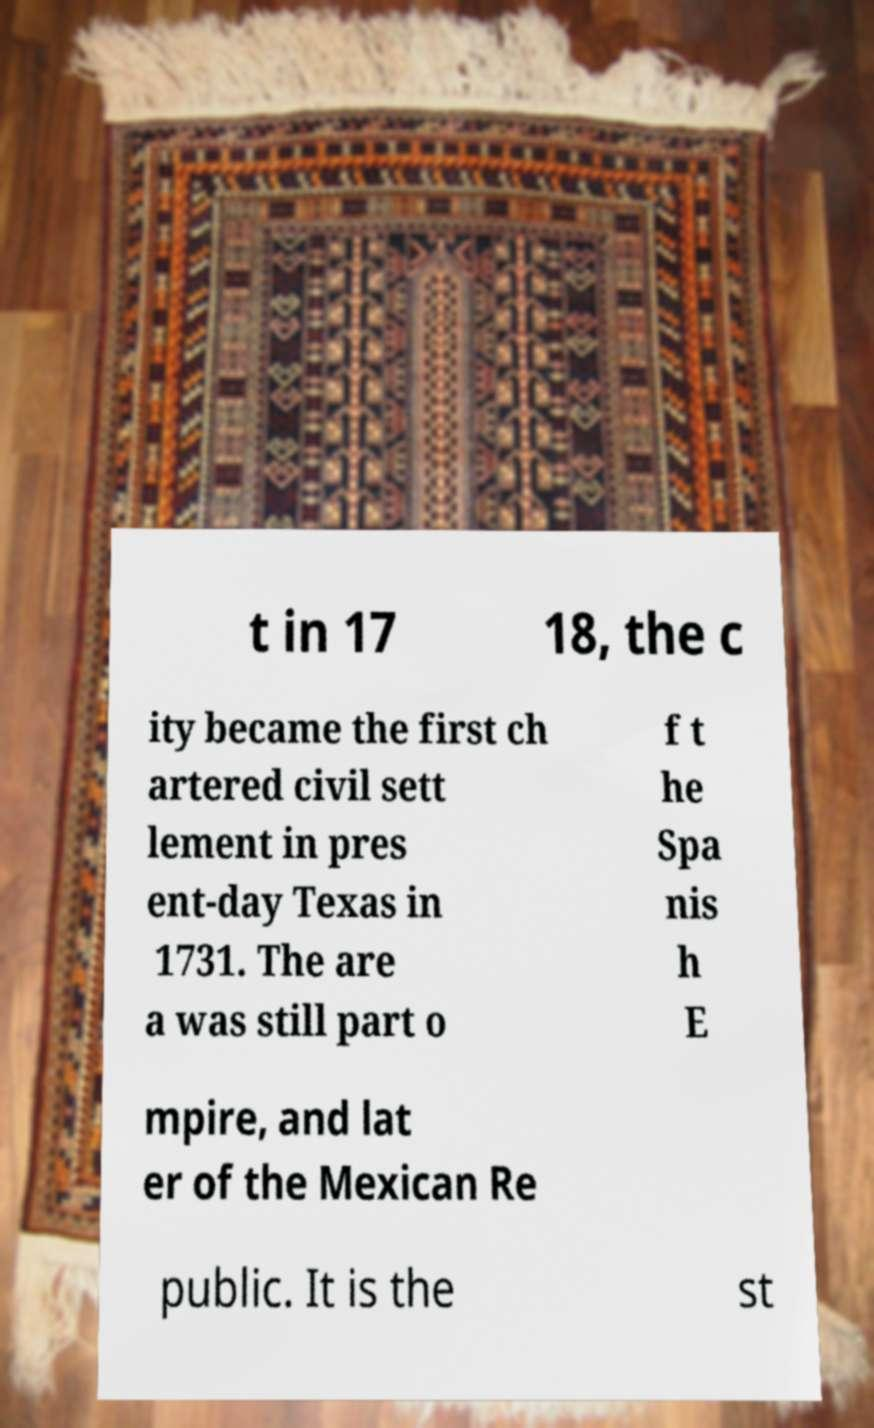Can you read and provide the text displayed in the image?This photo seems to have some interesting text. Can you extract and type it out for me? t in 17 18, the c ity became the first ch artered civil sett lement in pres ent-day Texas in 1731. The are a was still part o f t he Spa nis h E mpire, and lat er of the Mexican Re public. It is the st 